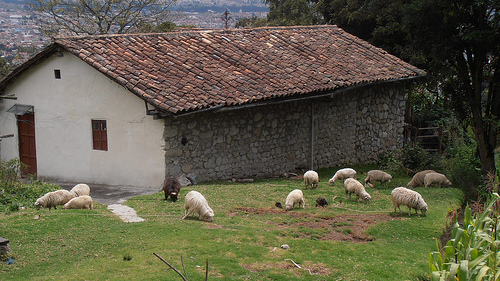<image>
Is the sheep next to the barn? Yes. The sheep is positioned adjacent to the barn, located nearby in the same general area. 